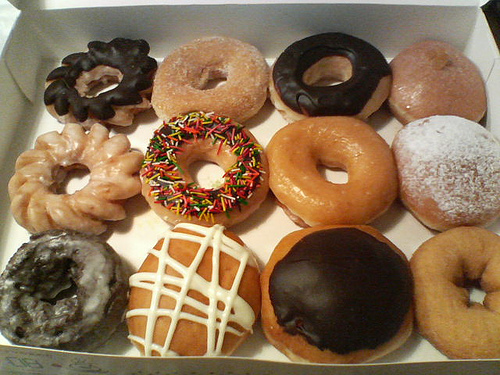How many different types of doughnuts are there? I can identify a total of 12 different types of doughnuts by their appearance, including glazed, frosted with sprinkles, powdered, and various others with unique toppings and flavors. 